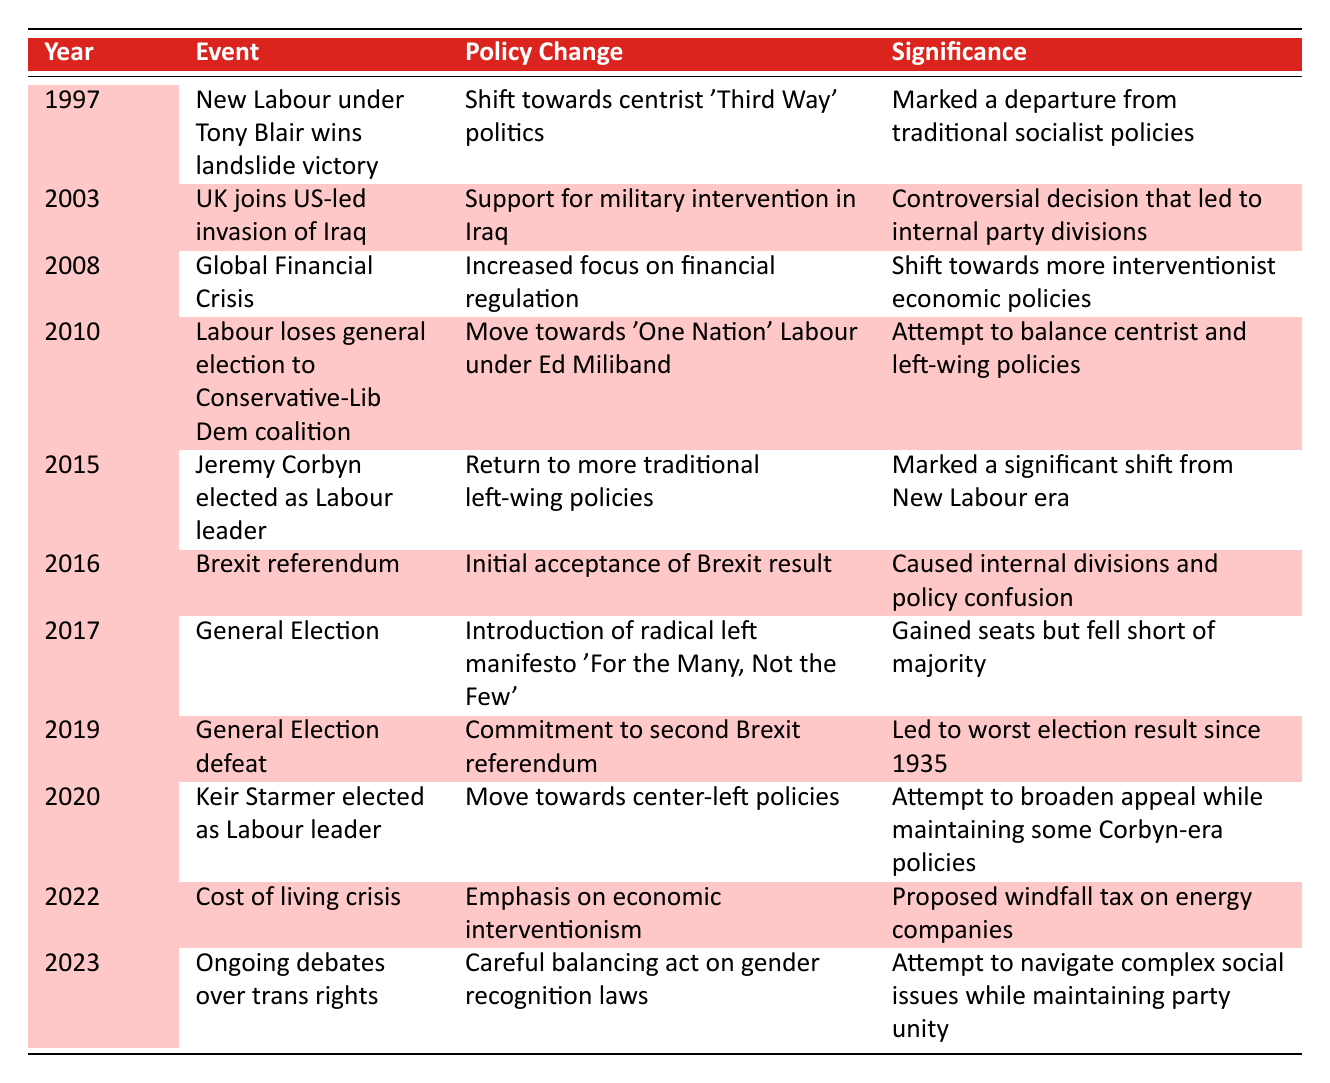What year did Jeremy Corbyn become the Labour leader? The table indicates that Jeremy Corbyn was elected as Labour leader in 2015.
Answer: 2015 What significant policy change occurred in 2003? The policy change in 2003 was the Labour Party's support for military intervention in Iraq.
Answer: Support for military intervention in Iraq Is the statement "Labour adopted more left-wing policies in 2020" true? In 2020, the Labour Party moved towards center-left policies under Keir Starmer, which indicates a less left-wing stance compared to Jeremy Corbyn's leadership.
Answer: False How many significant events involved a shift towards center-left policies? There are three events reflecting a shift towards center-left policies—2010 with Ed Miliband's 'One Nation' Labour, 2020 with Keir Starmer's leadership, and the 2017 election manifesto which included leftist ideals while attempting to appeal to a wider audience.
Answer: Three What was the significance of the 2019 General Election defeat? The significance was that it led to the worst election result since 1935, highlighting the party's struggles. This reflects the commitment to a second Brexit referendum that may have contributed to the loss.
Answer: Worst election result since 1935 What year marks a significant shift back to traditional left-wing policies under Jeremy Corbyn? The significant year of shift back to traditional left-wing policies was 2015 when Corbyn became leader.
Answer: 2015 Which event prompted increased focus on financial regulation? The event that prompted this focus was the Global Financial Crisis in 2008.
Answer: Global Financial Crisis in 2008 Considering the events listed, how many times did the Labour Party change its stance concerning Brexit between 2016 and 2019? The Labour Party changed its stance regarding Brexit twice; initially accepting the result in 2016 followed by a commitment to a second referendum in 2019.
Answer: Twice 